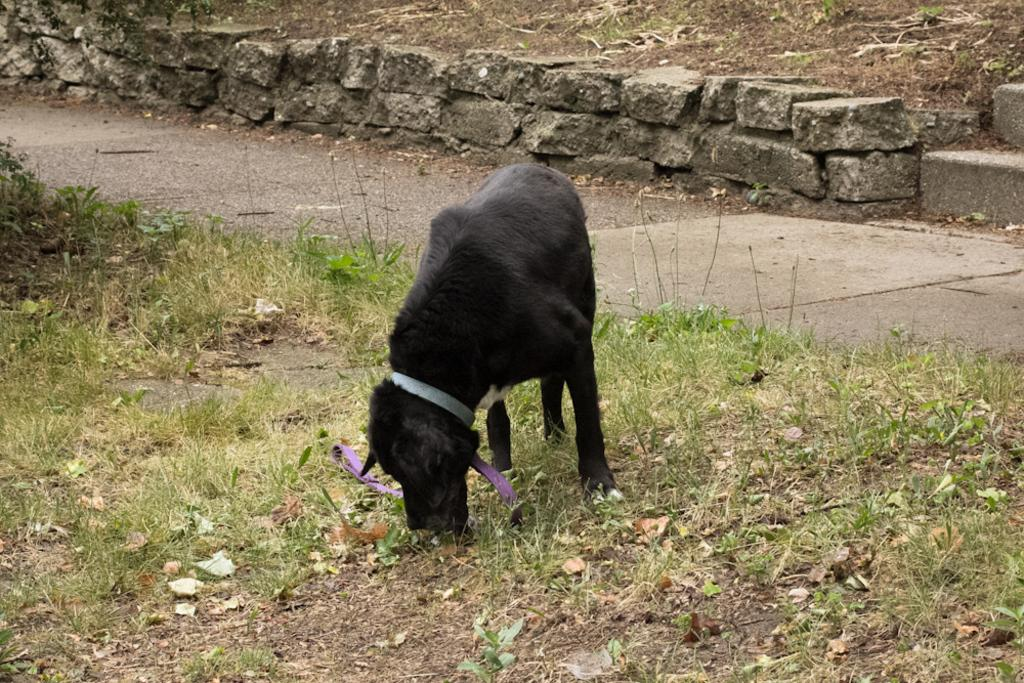What animal can be seen in the image? There is a dog in the image. Where is the dog standing? The dog is standing on the grass. What is behind the dog in the image? There is a walkway behind the dog. What types of terrain are visible at the top of the image? At the top of the image, there are rocks, sand, and grass. How does the dog react to the earthquake in the image? There is no earthquake present in the image, so the dog's reaction cannot be determined. 